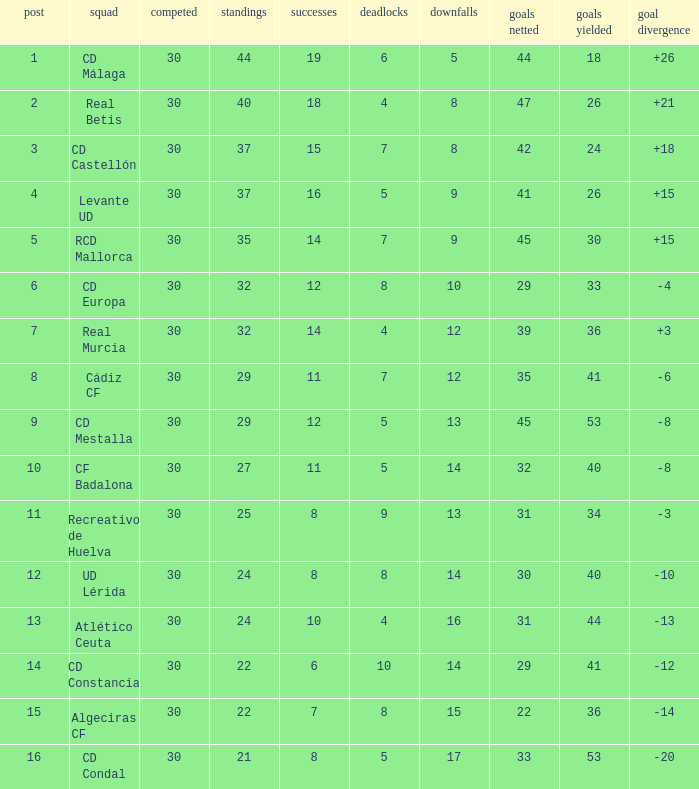What is the number of wins when the goals against is larger than 41, points is 29, and draws are larger than 5? 0.0. 